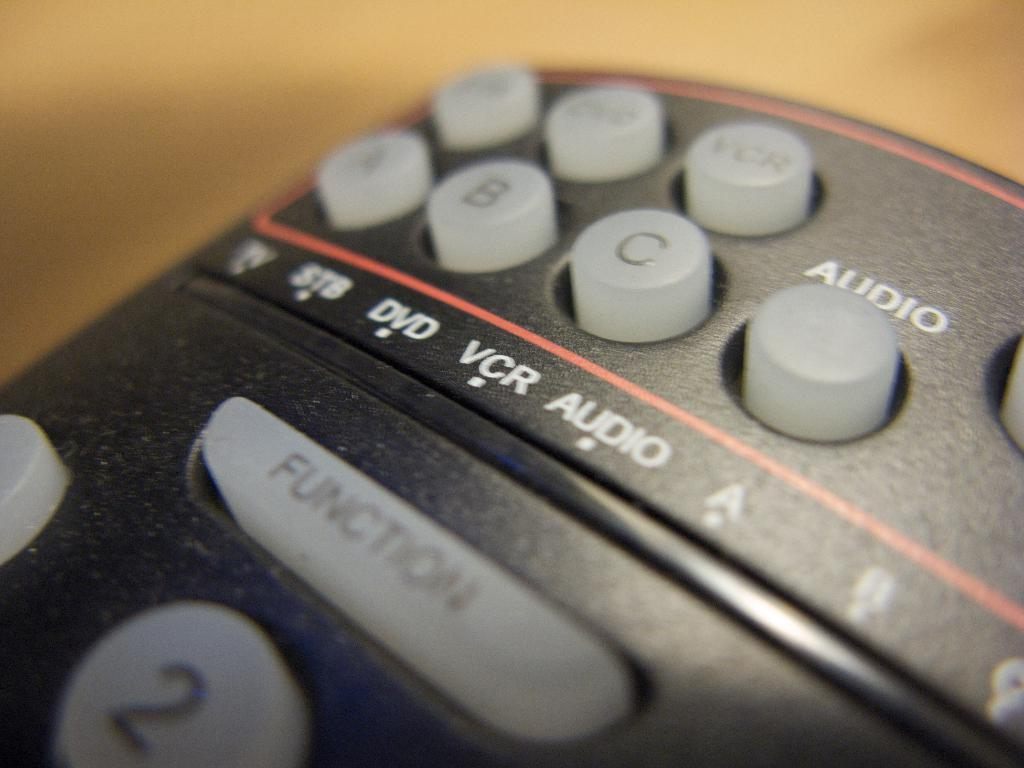<image>
Relay a brief, clear account of the picture shown. A black remote control with a large clear Function key on it. 